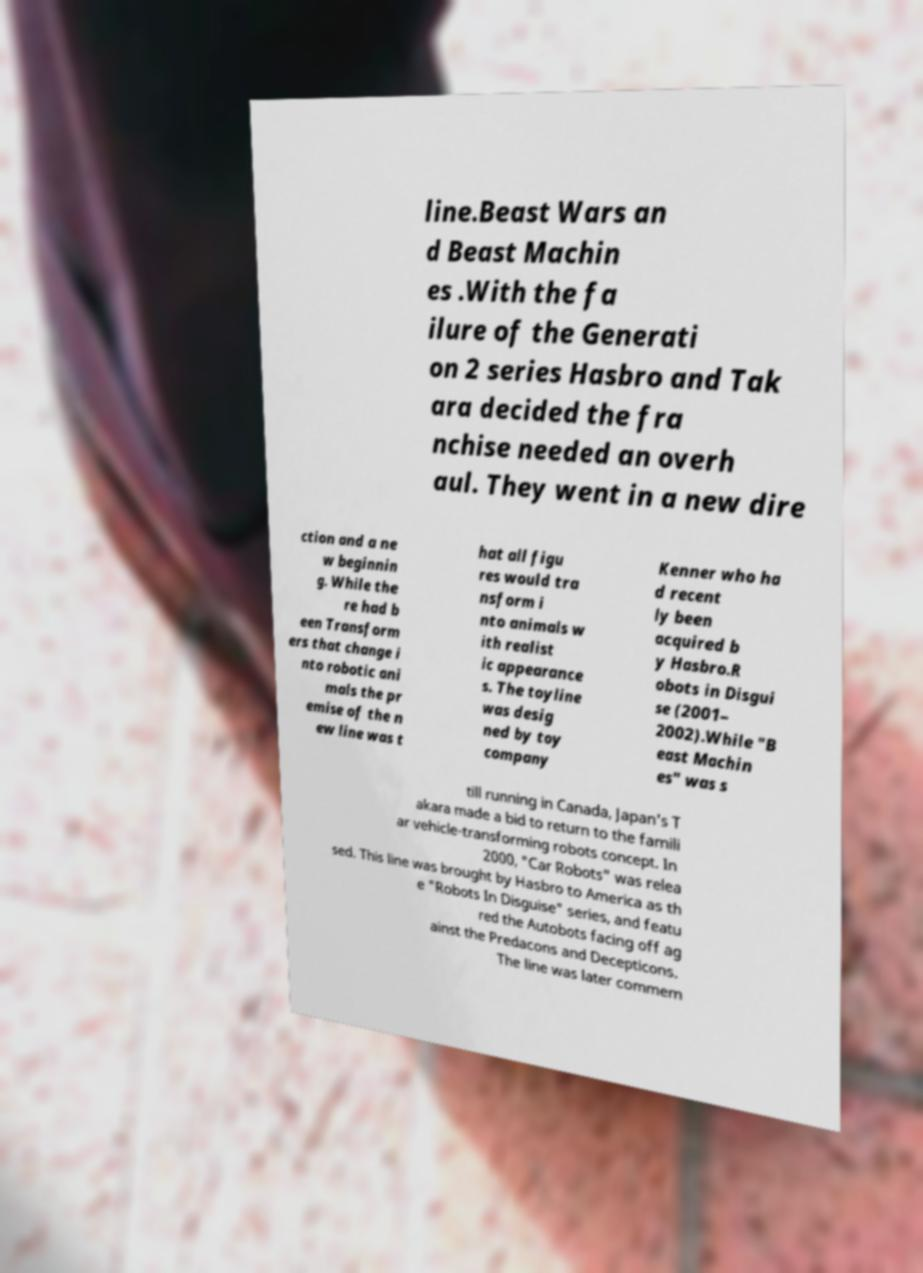There's text embedded in this image that I need extracted. Can you transcribe it verbatim? line.Beast Wars an d Beast Machin es .With the fa ilure of the Generati on 2 series Hasbro and Tak ara decided the fra nchise needed an overh aul. They went in a new dire ction and a ne w beginnin g. While the re had b een Transform ers that change i nto robotic ani mals the pr emise of the n ew line was t hat all figu res would tra nsform i nto animals w ith realist ic appearance s. The toyline was desig ned by toy company Kenner who ha d recent ly been acquired b y Hasbro.R obots in Disgui se (2001– 2002).While "B east Machin es" was s till running in Canada, Japan's T akara made a bid to return to the famili ar vehicle-transforming robots concept. In 2000, "Car Robots" was relea sed. This line was brought by Hasbro to America as th e "Robots In Disguise" series, and featu red the Autobots facing off ag ainst the Predacons and Decepticons. The line was later commem 